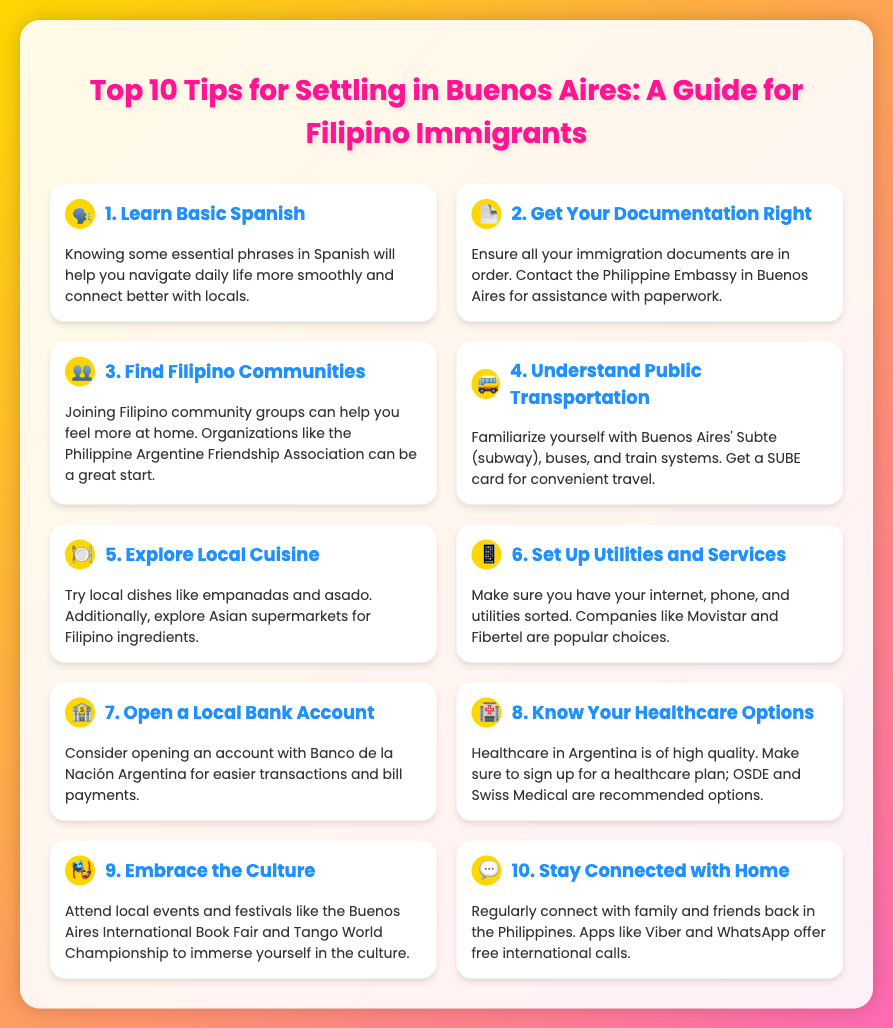1. What is the first tip for settling in Buenos Aires? The first tip for settling in Buenos Aires is "Learn Basic Spanish."
Answer: Learn Basic Spanish 2. Which organization is recommended for finding Filipino communities in Buenos Aires? The document suggests joining the "Philippine Argentine Friendship Association."
Answer: Philippine Argentine Friendship Association 3. What transportation card should newcomers get? The document mentions obtaining a "SUBE card" for convenient travel.
Answer: SUBE card 4. How many tips are listed in the document? The document lists a total of "10 tips" for settling in Buenos Aires.
Answer: 10 tips 5. What is advised for healthcare options? The document recommends signing up for a healthcare plan, mentioning "OSDE and Swiss Medical" as options.
Answer: OSDE and Swiss Medical 6. Why is opening a local bank account recommended? The document explains that it facilitates "easier transactions and bill payments."
Answer: Easier transactions and bill payments 7. What type of cuisine should newcomers explore? The document encourages trying "local dishes like empanadas and asado."
Answer: Local dishes like empanadas and asado 8. What should immigrants do to stay connected with home? It is advised to regularly connect with family and friends back home using apps like "Viber and WhatsApp."
Answer: Viber and WhatsApp 9. What is the color of the poster's background? The background of the poster has a gradient of "gold and pink."
Answer: Gold and pink 10. Which company is mentioned for internet and phone services? The document mentions "Movistar and Fibertel" as popular choices for utilities.
Answer: Movistar and Fibertel 